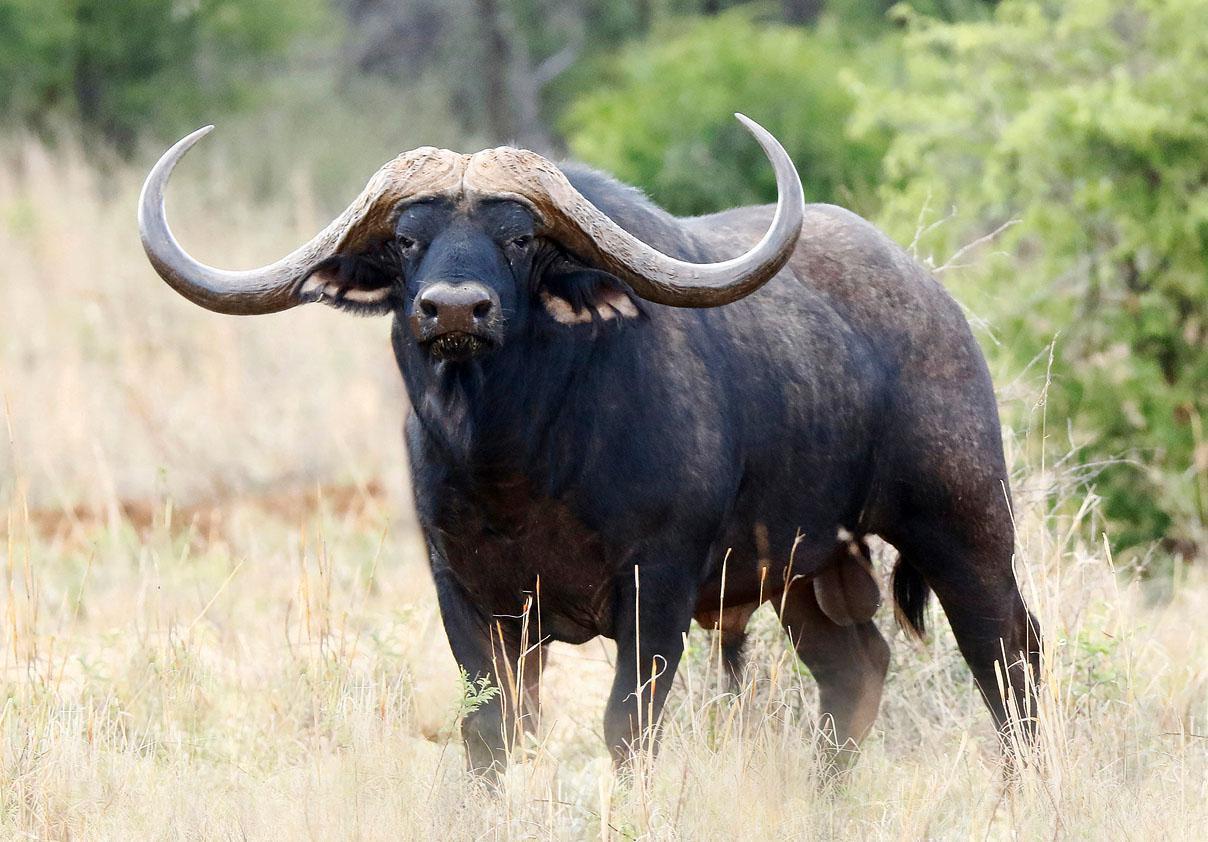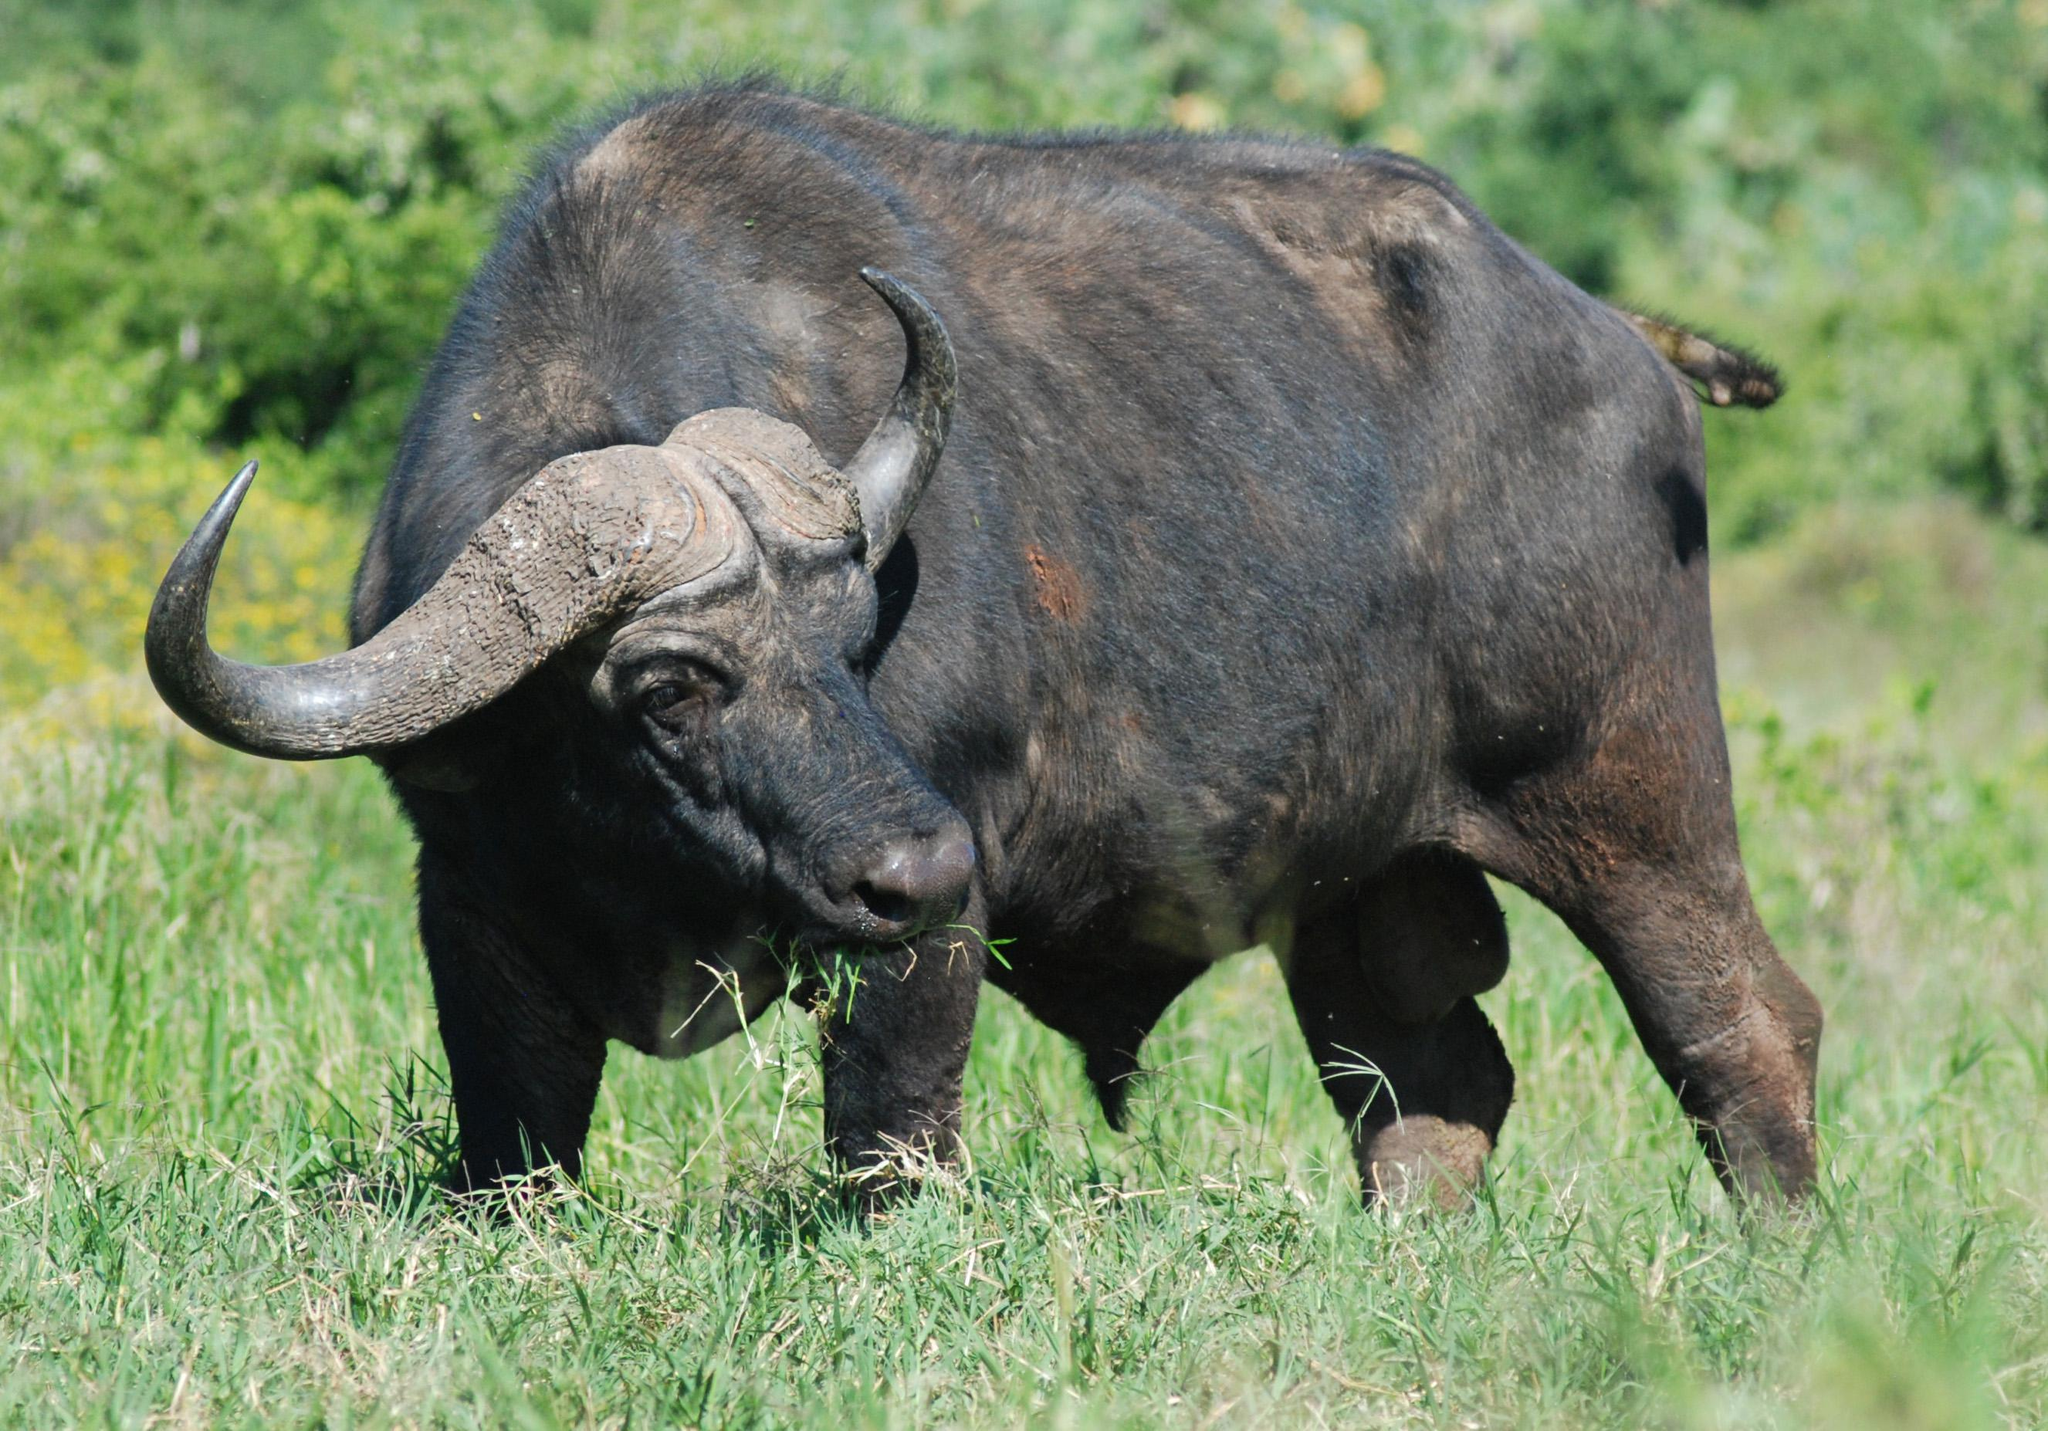The first image is the image on the left, the second image is the image on the right. For the images displayed, is the sentence "One of the images contains more than one water buffalo." factually correct? Answer yes or no. No. 